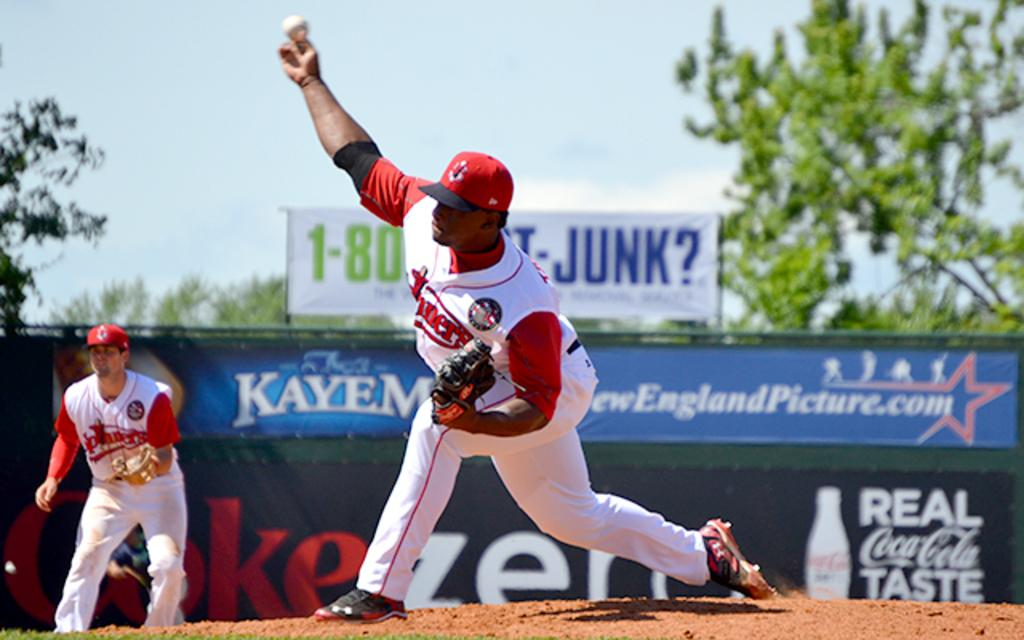Provide a one-sentence caption for the provided image. Baseball player wearing a white jersey that says miners. 